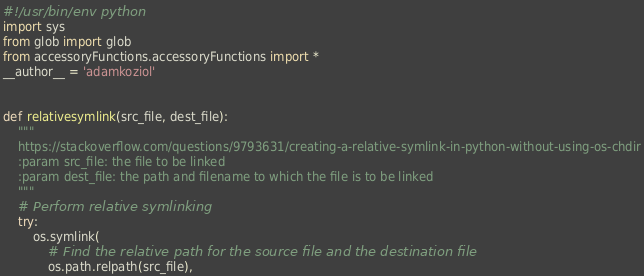<code> <loc_0><loc_0><loc_500><loc_500><_Python_>#!/usr/bin/env python
import sys
from glob import glob
from accessoryFunctions.accessoryFunctions import *
__author__ = 'adamkoziol'


def relativesymlink(src_file, dest_file):
    """
    https://stackoverflow.com/questions/9793631/creating-a-relative-symlink-in-python-without-using-os-chdir
    :param src_file: the file to be linked
    :param dest_file: the path and filename to which the file is to be linked
    """
    # Perform relative symlinking
    try:
        os.symlink(
            # Find the relative path for the source file and the destination file
            os.path.relpath(src_file),</code> 